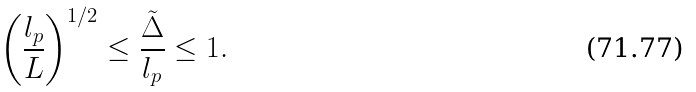Convert formula to latex. <formula><loc_0><loc_0><loc_500><loc_500>\left ( \frac { l _ { p } } { L } \right ) ^ { 1 / 2 } \leq \frac { \tilde { \Delta } } { l _ { p } } \leq 1 .</formula> 